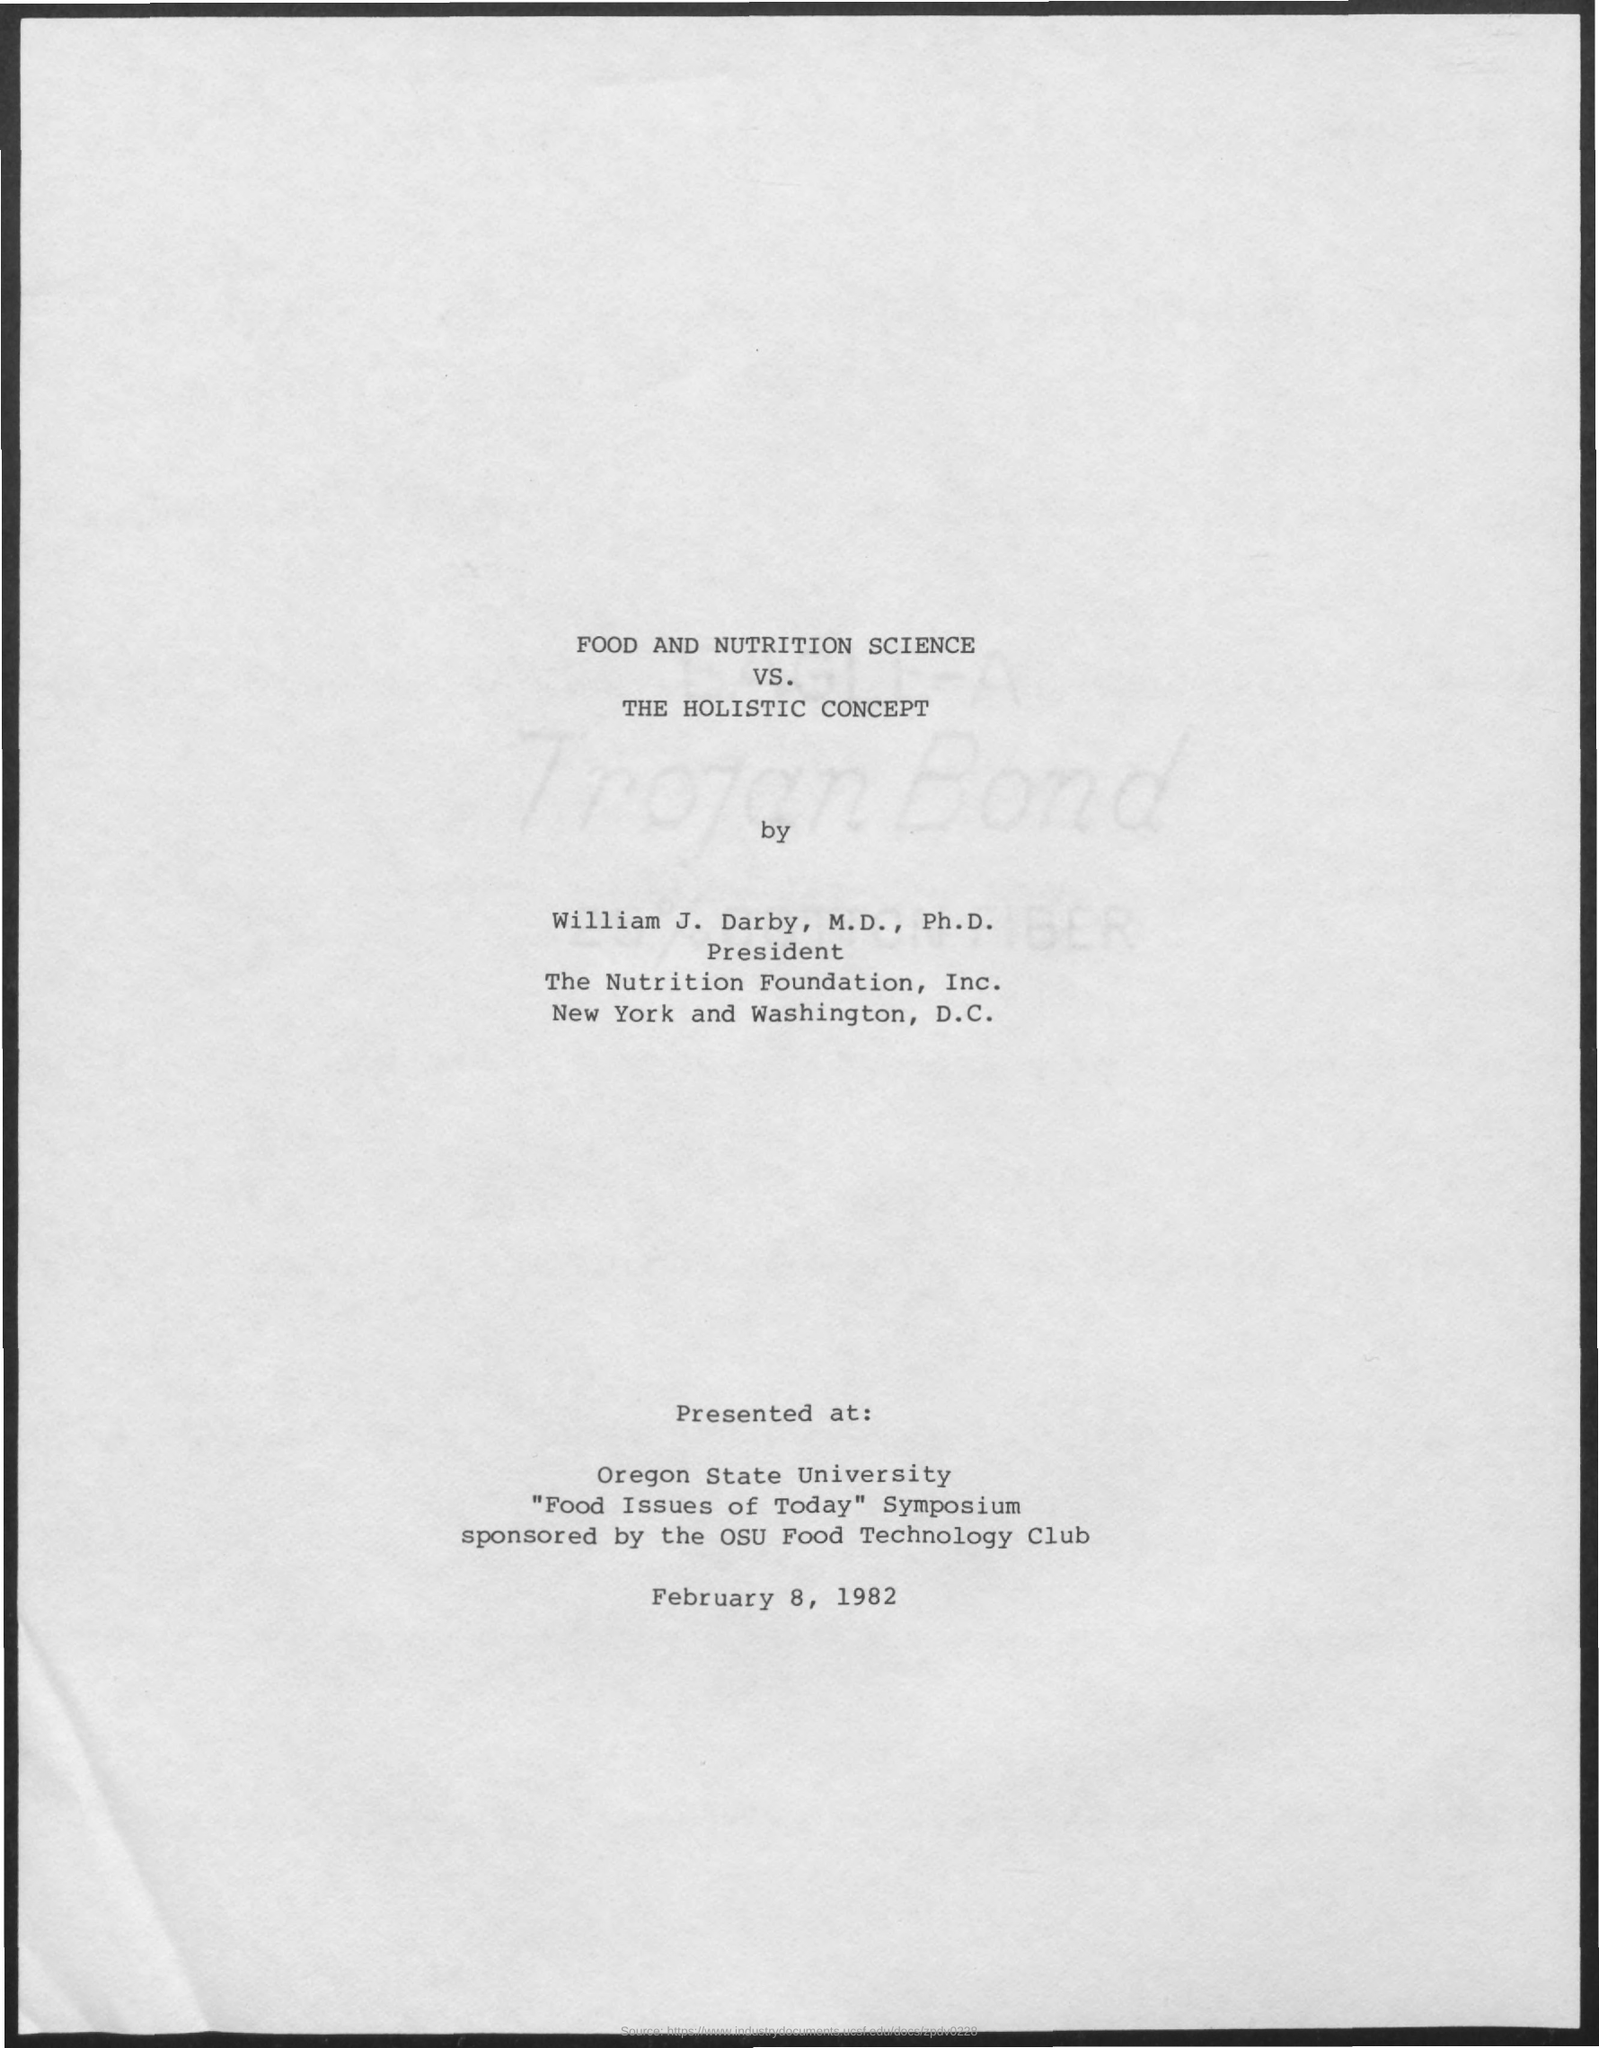Mention a couple of crucial points in this snapshot. The OSU Food Technology Club is the sponsor of this event. When was it presented? On February 8, 1982. The presentation was presented at Oregon State University. The Nutrition Foundation, Inc. is located in both New York and Washington, D.C. The article "Food and Nutrition Science VS. The Holistic Concept" was written by William J. Darby. 